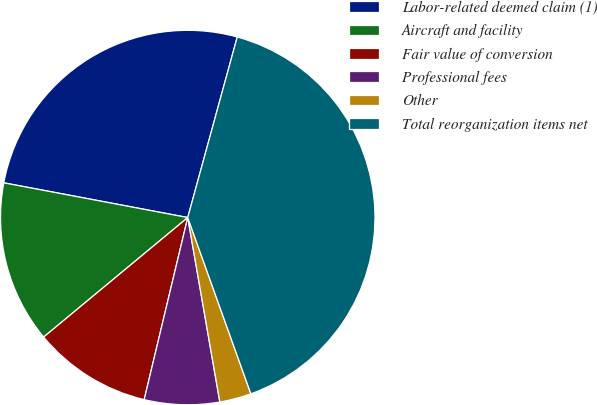Convert chart. <chart><loc_0><loc_0><loc_500><loc_500><pie_chart><fcel>Labor-related deemed claim (1)<fcel>Aircraft and facility<fcel>Fair value of conversion<fcel>Professional fees<fcel>Other<fcel>Total reorganization items net<nl><fcel>26.29%<fcel>13.99%<fcel>10.24%<fcel>6.48%<fcel>2.73%<fcel>40.27%<nl></chart> 